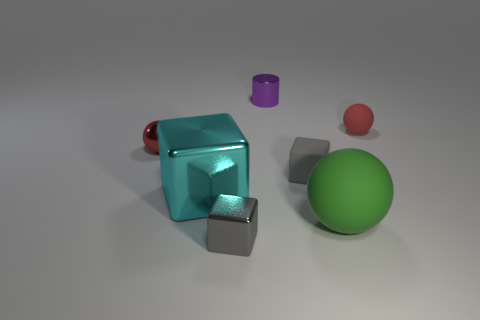The red metal object that is the same size as the purple metallic object is what shape?
Your answer should be very brief. Sphere. What number of things are large rubber spheres that are on the right side of the small purple cylinder or rubber objects behind the big green matte thing?
Ensure brevity in your answer.  3. Is the number of gray rubber cubes less than the number of large red rubber cubes?
Offer a very short reply. No. There is another sphere that is the same size as the metal sphere; what is it made of?
Provide a short and direct response. Rubber. Is the size of the rubber ball that is to the right of the green sphere the same as the red metal thing that is in front of the red matte thing?
Give a very brief answer. Yes. Are there any tiny green things made of the same material as the large cyan block?
Keep it short and to the point. No. What number of things are either cubes to the right of the small gray metallic object or yellow matte balls?
Your response must be concise. 1. Are the red ball that is in front of the red rubber thing and the purple thing made of the same material?
Your response must be concise. Yes. Do the large green matte object and the tiny red shiny thing have the same shape?
Offer a terse response. Yes. There is a gray rubber cube to the left of the large green ball; what number of tiny objects are in front of it?
Keep it short and to the point. 1. 